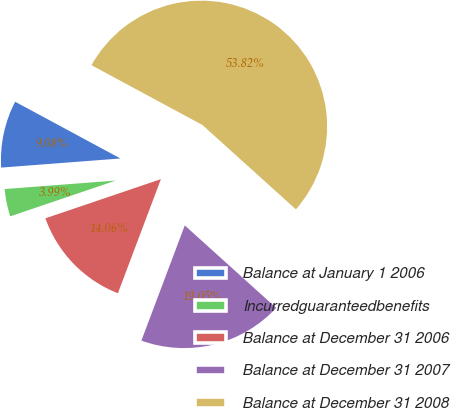Convert chart. <chart><loc_0><loc_0><loc_500><loc_500><pie_chart><fcel>Balance at January 1 2006<fcel>Incurredguaranteedbenefits<fcel>Balance at December 31 2006<fcel>Balance at December 31 2007<fcel>Balance at December 31 2008<nl><fcel>9.08%<fcel>3.99%<fcel>14.06%<fcel>19.05%<fcel>53.82%<nl></chart> 